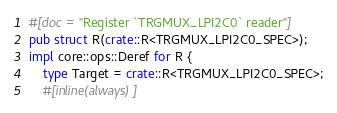Convert code to text. <code><loc_0><loc_0><loc_500><loc_500><_Rust_>#[doc = "Register `TRGMUX_LPI2C0` reader"]
pub struct R(crate::R<TRGMUX_LPI2C0_SPEC>);
impl core::ops::Deref for R {
    type Target = crate::R<TRGMUX_LPI2C0_SPEC>;
    #[inline(always)]</code> 